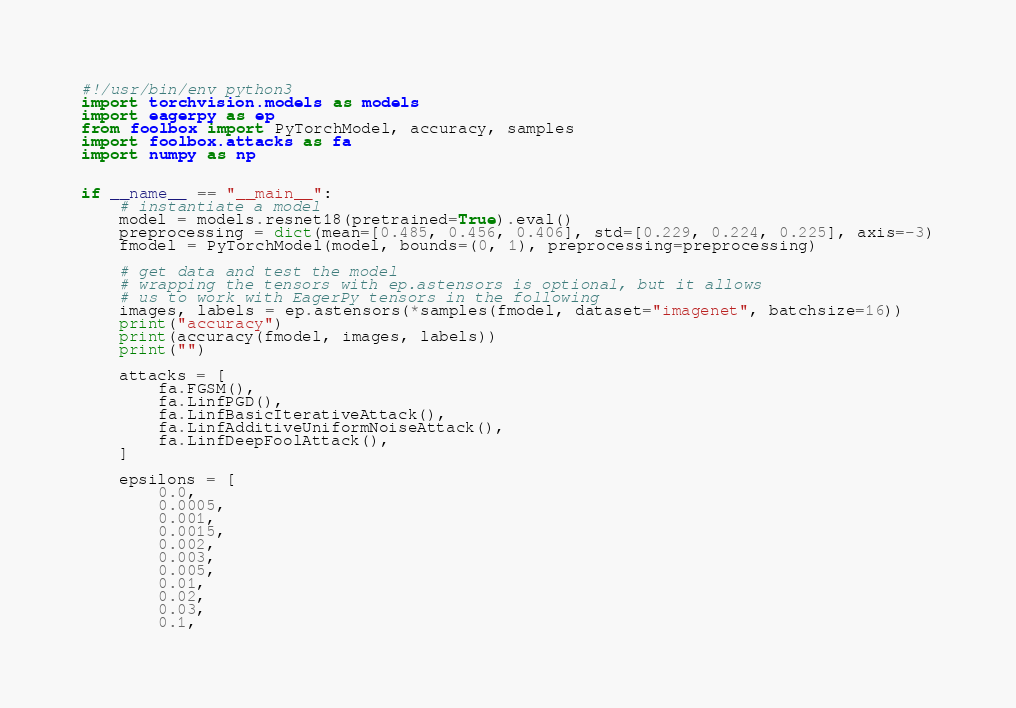Convert code to text. <code><loc_0><loc_0><loc_500><loc_500><_Python_>#!/usr/bin/env python3
import torchvision.models as models
import eagerpy as ep
from foolbox import PyTorchModel, accuracy, samples
import foolbox.attacks as fa
import numpy as np


if __name__ == "__main__":
    # instantiate a model
    model = models.resnet18(pretrained=True).eval()
    preprocessing = dict(mean=[0.485, 0.456, 0.406], std=[0.229, 0.224, 0.225], axis=-3)
    fmodel = PyTorchModel(model, bounds=(0, 1), preprocessing=preprocessing)

    # get data and test the model
    # wrapping the tensors with ep.astensors is optional, but it allows
    # us to work with EagerPy tensors in the following
    images, labels = ep.astensors(*samples(fmodel, dataset="imagenet", batchsize=16))
    print("accuracy")
    print(accuracy(fmodel, images, labels))
    print("")

    attacks = [
        fa.FGSM(),
        fa.LinfPGD(),
        fa.LinfBasicIterativeAttack(),
        fa.LinfAdditiveUniformNoiseAttack(),
        fa.LinfDeepFoolAttack(),
    ]

    epsilons = [
        0.0,
        0.0005,
        0.001,
        0.0015,
        0.002,
        0.003,
        0.005,
        0.01,
        0.02,
        0.03,
        0.1,</code> 